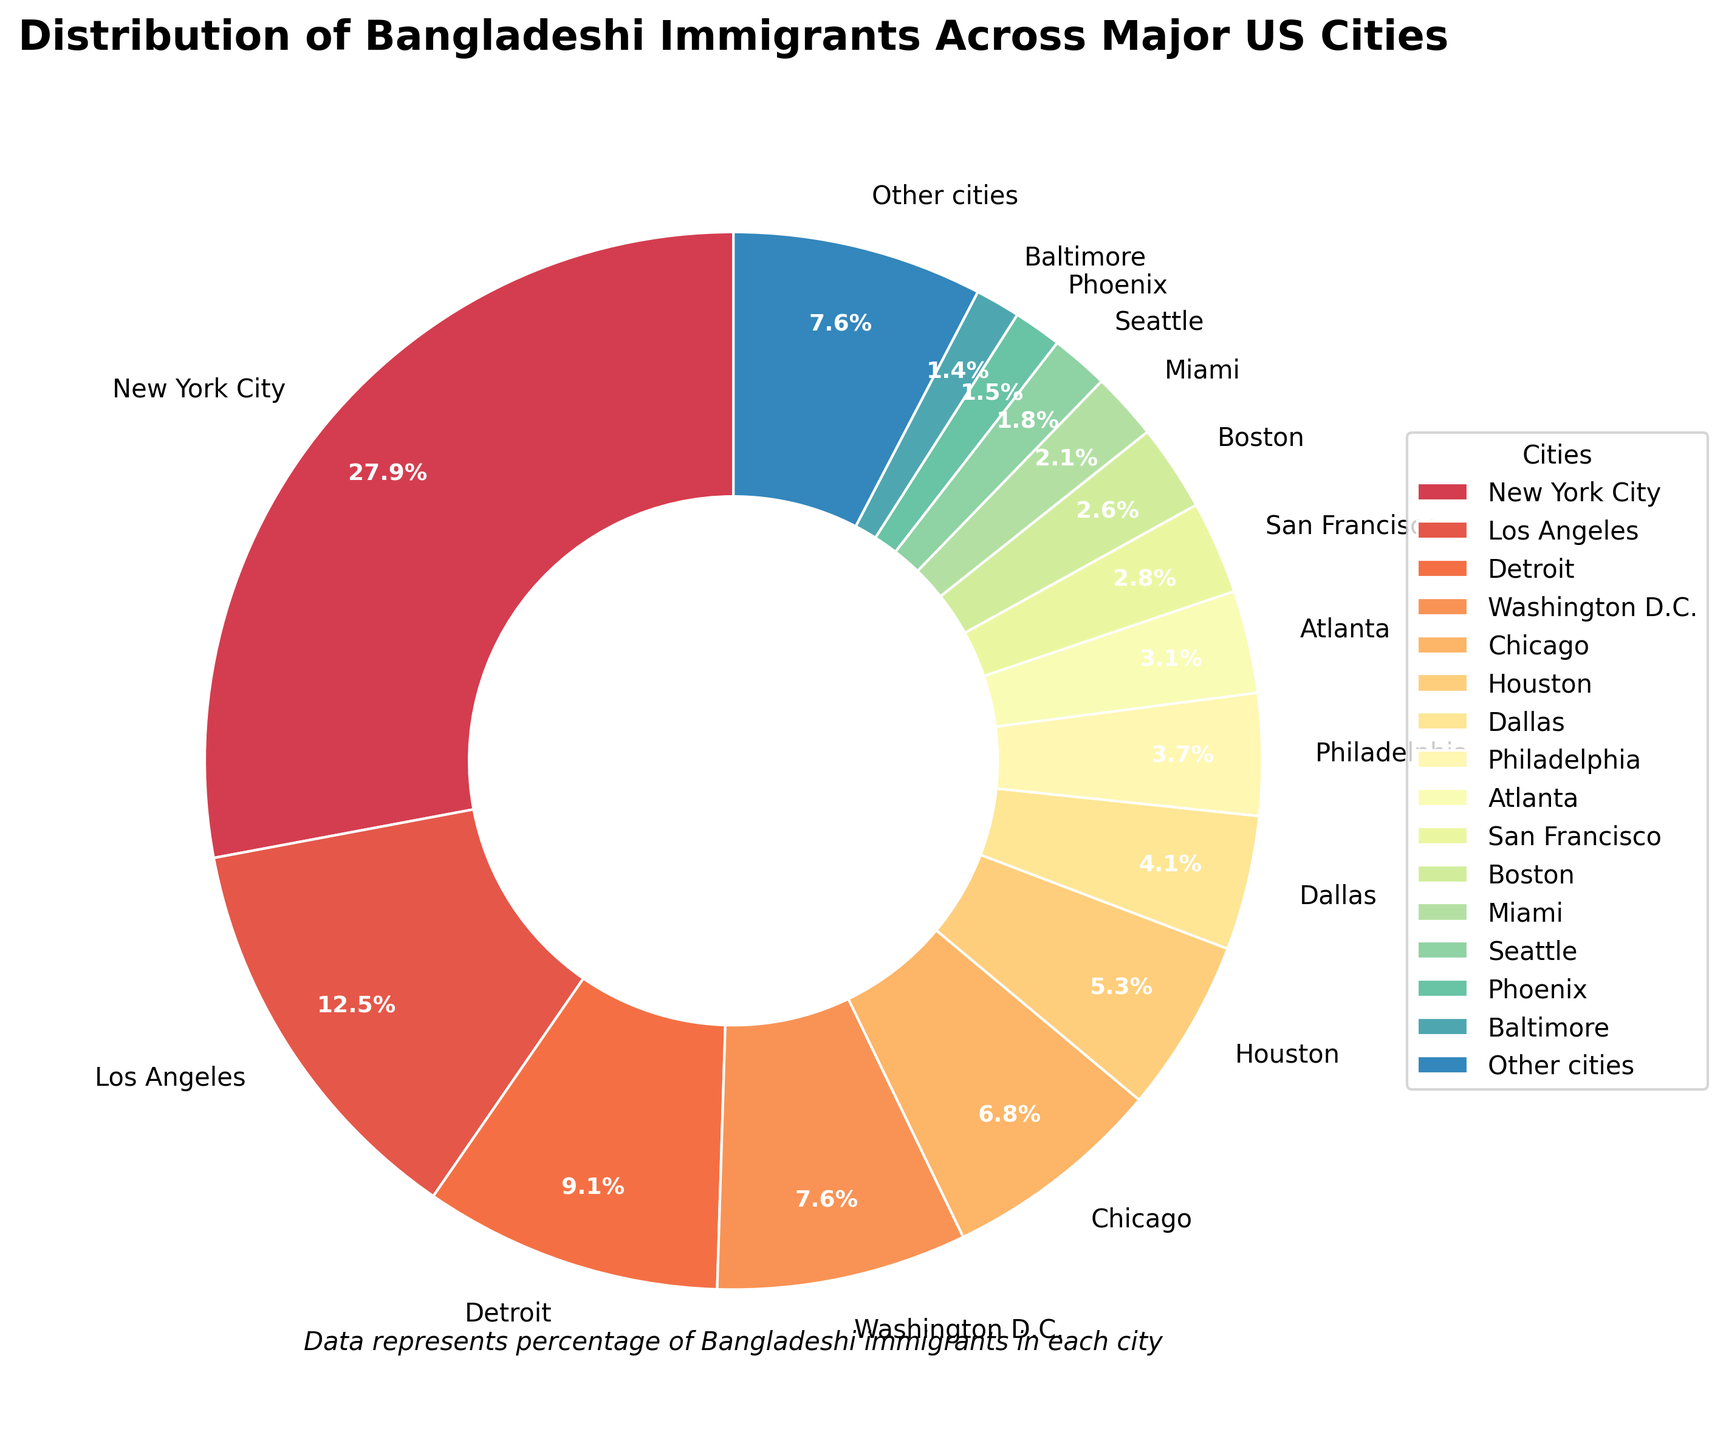What's the city with the highest percentage of Bangladeshi immigrants? By observing the pie chart, New York City has the largest wedge, representing the highest percentage of Bangladeshi immigrants as indicated by the chart label.
Answer: New York City Which city has a higher percentage of Bangladeshi immigrants: Los Angeles or Chicago? Comparing the wedges for Los Angeles and Chicago, Los Angeles has a larger wedge with 12.7%, whereas Chicago has a smaller wedge with 6.9%.
Answer: Los Angeles What is the combined percentage of Bangladeshi immigrants in New York City and Los Angeles? Summing the percentages of New York City (28.5%) and Los Angeles (12.7%) gives 28.5 + 12.7 = 41.2%.
Answer: 41.2% How many cities have a percentage of Bangladeshi immigrants lower than 5%? From the pie chart, we can identify Dallas (4.2%), Philadelphia (3.8%), Atlanta (3.2%), San Francisco (2.9%), Boston (2.7%), Miami (2.1%), Seattle (1.8%), Phoenix (1.5%), Baltimore (1.4%). That sums up to 9 cities.
Answer: 9 cities Is the percentage of Bangladeshi immigrants in Washington D.C. higher or lower than in Houston? The pie chart shows that Washington D.C. has 7.8% while Houston has 5.4%, indicating that Washington D.C. has a higher percentage.
Answer: Higher Which city represents roughly one-fifth the percentage of New York City? New York City's percentage is 28.5%. One-fifth of this is approximately 28.5 / 5 = 5.7%. Houston, with 5.4%, is closest to this percentage.
Answer: Houston What is the difference in percentage between Detroit and Dallas? The percentages for Detroit and Dallas are 9.3% and 4.2% respectively. Subtracting these gives 9.3 - 4.2 = 5.1%.
Answer: 5.1% Which two cities combined have the same percentage as New York City? The percentages of Detroit (9.3%) and Los Angeles (12.7%) sum to 9.3 + 12.7 = 22%. Neither of the other cities combine to 28.5% exactly, so no exact match.
Answer: No exact match What percentage of Bangladeshi immigrants live in cities other than the ones explicitly listed? According to the pie chart, the category "Other cities" stands for 7.8%.
Answer: 7.8% Is the combined percentage of Bangladeshi immigrants in Chicago, Houston, and Dallas greater or less than in New York City? The sum of the percentages for Chicago (6.9%), Houston (5.4%), and Dallas (4.2%) is 6.9 + 5.4 + 4.2 = 16.5%. This is less than New York City's 28.5%.
Answer: Less 